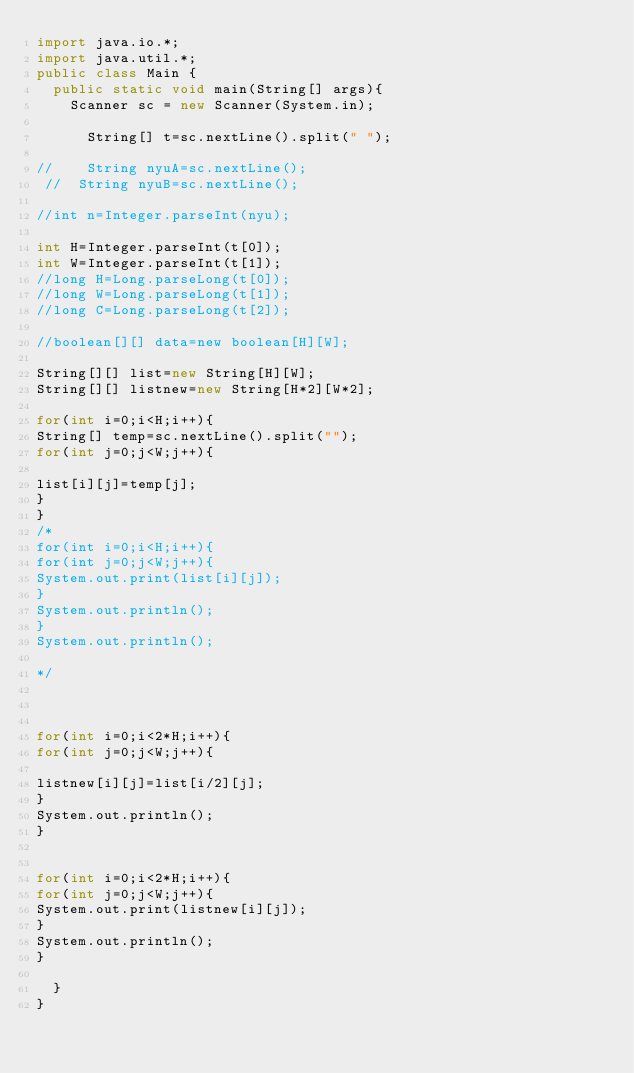<code> <loc_0><loc_0><loc_500><loc_500><_Java_>import java.io.*;
import java.util.*;
public class Main {
	public static void main(String[] args){
		Scanner sc = new Scanner(System.in);
 
      String[] t=sc.nextLine().split(" ");
 
//    String nyuA=sc.nextLine();
 //  String nyuB=sc.nextLine();

//int n=Integer.parseInt(nyu);

int H=Integer.parseInt(t[0]);
int W=Integer.parseInt(t[1]);
//long H=Long.parseLong(t[0]);
//long W=Long.parseLong(t[1]);
//long C=Long.parseLong(t[2]);

//boolean[][] data=new boolean[H][W];

String[][] list=new String[H][W];
String[][] listnew=new String[H*2][W*2];

for(int i=0;i<H;i++){
String[] temp=sc.nextLine().split("");
for(int j=0;j<W;j++){

list[i][j]=temp[j];
}
}
/*
for(int i=0;i<H;i++){
for(int j=0;j<W;j++){
System.out.print(list[i][j]);
}
System.out.println();
}
System.out.println();

*/



for(int i=0;i<2*H;i++){
for(int j=0;j<W;j++){

listnew[i][j]=list[i/2][j];
}
System.out.println();
}


for(int i=0;i<2*H;i++){
for(int j=0;j<W;j++){
System.out.print(listnew[i][j]);
}
System.out.println();
}

	}
}</code> 